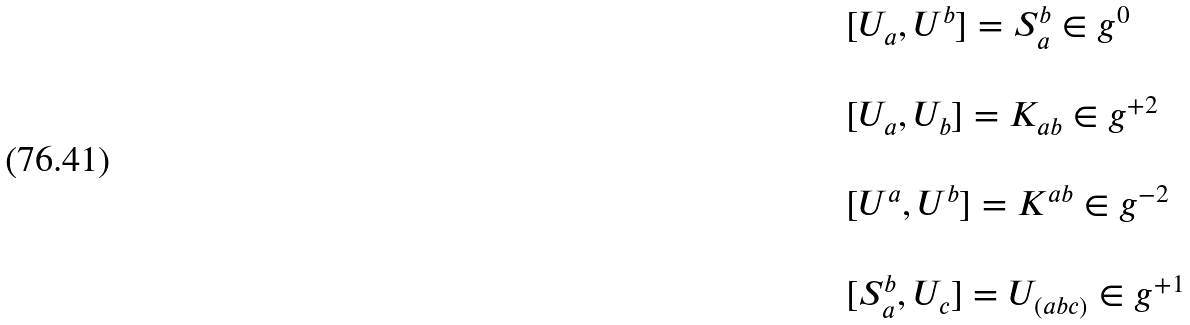Convert formula to latex. <formula><loc_0><loc_0><loc_500><loc_500>\begin{array} { l } { [ } U _ { a } , U ^ { b } { ] } = S _ { a } ^ { b } \in g ^ { 0 } \\ \ \\ { [ } U _ { a } , U _ { b } { ] } = K _ { a b } \in g ^ { + 2 } \\ \ \\ { [ } U ^ { a } , U ^ { b } { ] } = K ^ { a b } \in g ^ { - 2 } \\ \ \\ { [ } S _ { a } ^ { b } , U _ { c } { ] } = U _ { ( a b c ) } \in g ^ { + 1 } \end{array}</formula> 